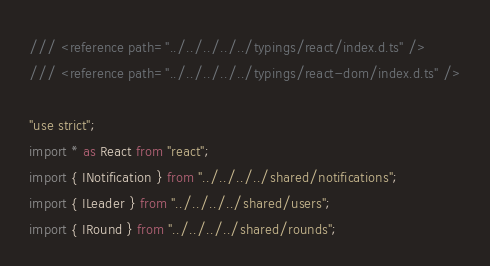Convert code to text. <code><loc_0><loc_0><loc_500><loc_500><_TypeScript_>/// <reference path="../../../../../typings/react/index.d.ts" />
/// <reference path="../../../../../typings/react-dom/index.d.ts" />

"use strict";
import * as React from "react";
import { INotification } from "../../../../shared/notifications";
import { ILeader } from "../../../../shared/users";
import { IRound } from "../../../../shared/rounds";</code> 